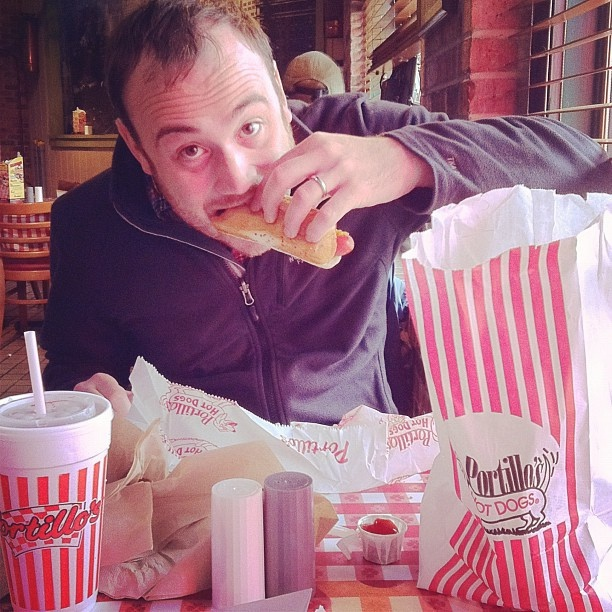Describe the objects in this image and their specific colors. I can see dining table in black, lavender, lightpink, brown, and salmon tones, people in black, purple, lightpink, and lavender tones, cup in black, lavender, darkgray, pink, and lightpink tones, chair in black, maroon, and brown tones, and hot dog in black, lightpink, brown, and salmon tones in this image. 